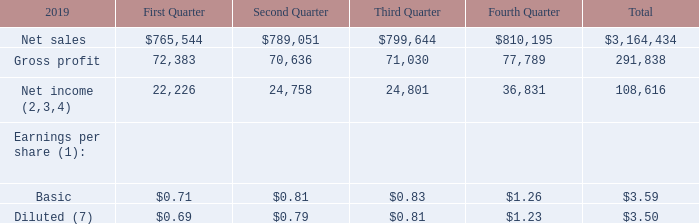17. Quarterly Financial Data (Unaudited)
The following is summarized quarterly financial data for fiscal 2019 and 2018 (in thousands, except per share amounts):
(1) The annual total amounts may not equal the sum of the quarterly amounts due to rounding. Earnings per share is computed independently for each quarter.
(2) The first quarter of fiscal 2019 results included $7.0 million of tax expense as a result of new regulations issued in November 2018 under Tax Reform. These regulations impacted the treatment of foreign taxes paid.
(3) The fourth quarter of fiscal 2019 results included restructuring costs of $1.7 million, $1.5 million net of taxes.
(4) The fourth quarter of fiscal 2019 results included the permanent reinvestment assertion of $10.5 million of certain historical undistributed earnings of two foreign subsidiaries.
(7) The first quarter of fiscal 2019 included $0.23 per share of tax expense as a result of U.S. Tax Reform. The fourth quarter of fiscal 2019 included $0.05 per share of expense related to restructuring costs and $0.35 per share tax benefit resulting from the permanent reinvestment assertion of certain historical undistributed earnings of two foreign subsidiaries.
What was the net sales in the first quarter?
Answer scale should be: thousand. 765,544. What was the gross profit in the Third quarter?
Answer scale should be: thousand. 71,030. What was the total net income?
Answer scale should be: thousand. 108,616. How many quarters did net sales exceed $800,000 thousand? Fourth Quarter
Answer: 1. What was the change in the gross profit between the first and second quarter?
Answer scale should be: thousand. 70,636-72,383
Answer: -1747. What was the percentage change in the basic earnings per share between the third and fourth quarter?
Answer scale should be: percent. (1.26-0.83)/0.83
Answer: 51.81. 